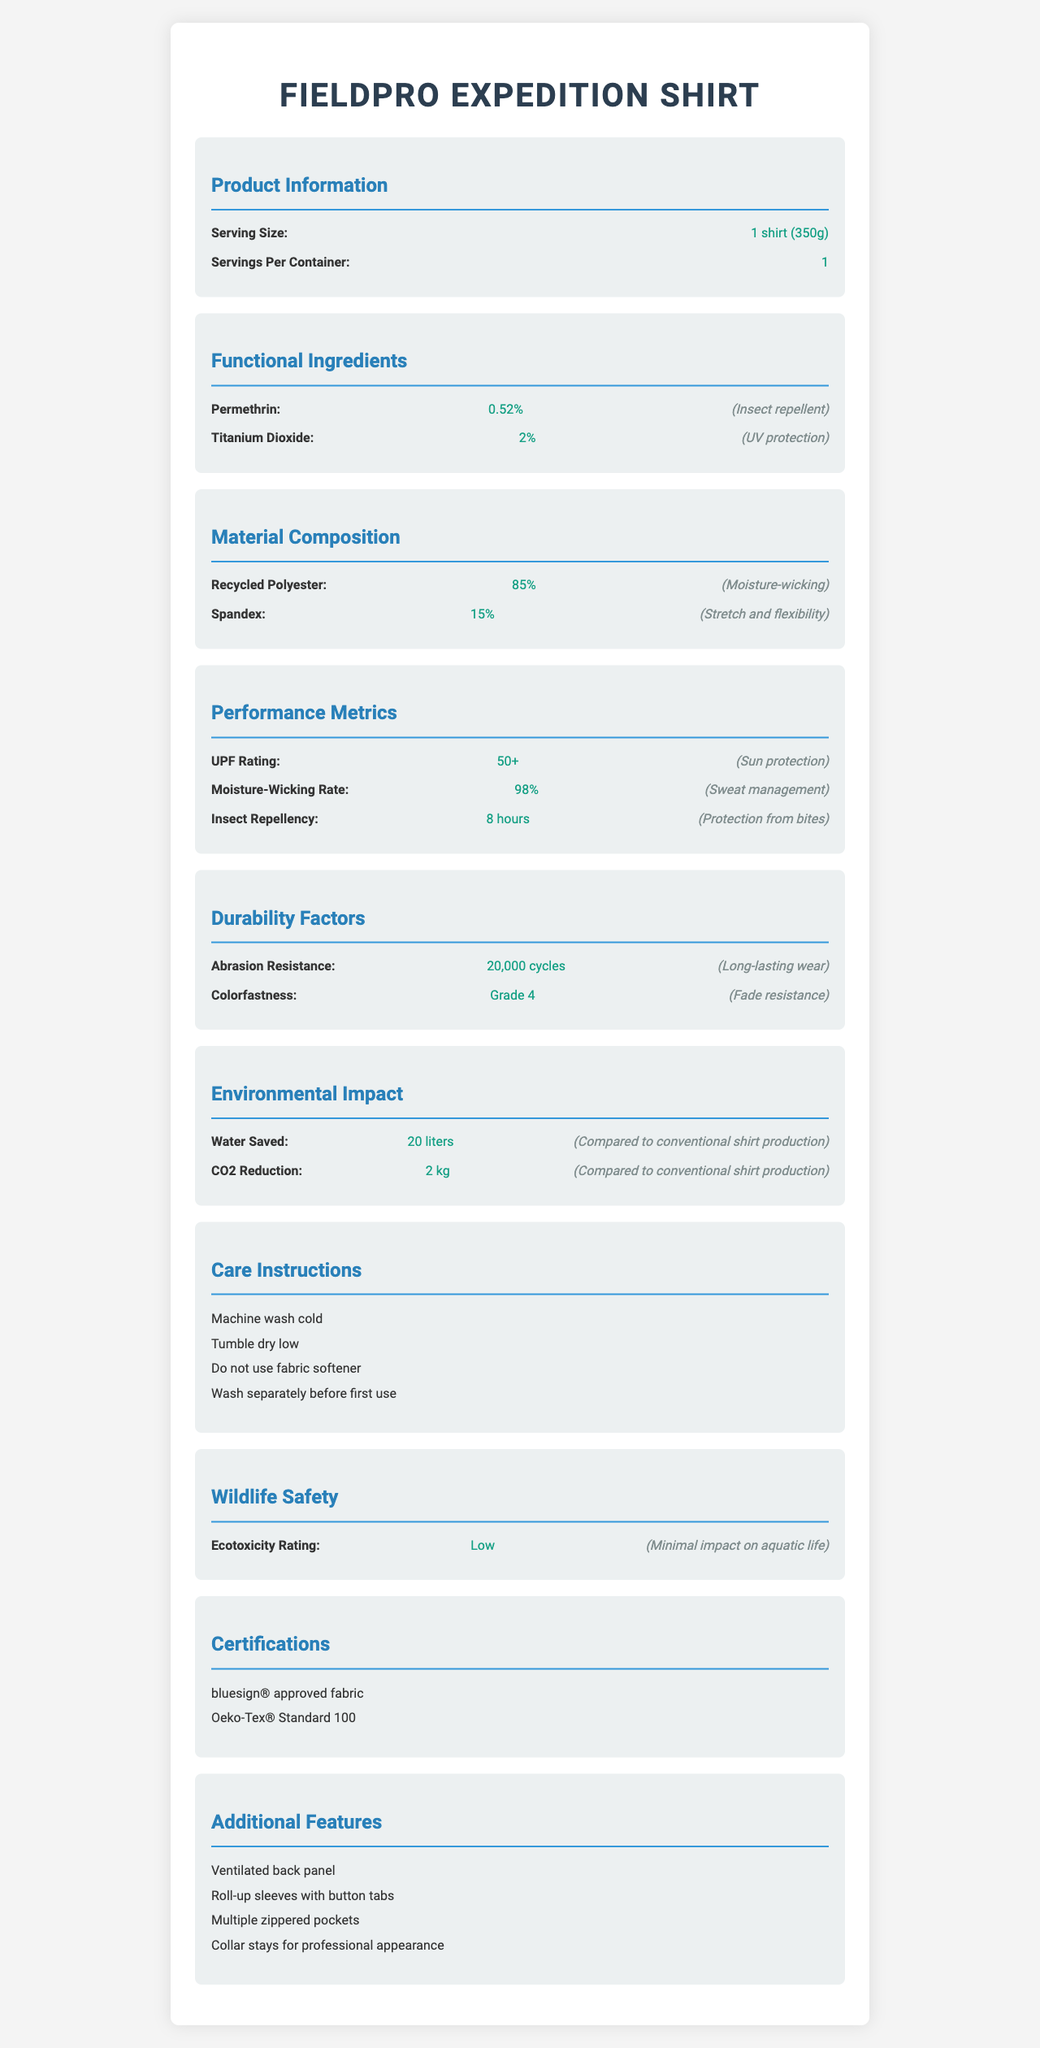what is the serving size for the FieldPro Expedition Shirt? The serving size is provided in the document under "Product Information" and is listed as "1 shirt (350g)".
Answer: 1 shirt (350g) how many servings are there per container? The document states under the "Product Information" section that there is 1 serving per container.
Answer: 1 what is the UPF rating of the shirt? The UPF rating is found under the "Performance Metrics" section, and it is listed as 50+.
Answer: 50+ what percentage of the shirt's material is recycled polyester? The "Material Composition" section lists that 85% of the shirt is made of Recycled Polyester.
Answer: 85% how much spandex is in the shirt's material composition? The "Material Composition" section shows that the shirt contains 15% Spandex.
Answer: 15% what is the main benefit of Permethrin in the shirt? The document lists Permethrin in the "Functional Ingredients" section, with its benefit specified as "Insect repellent".
Answer: Insect repellent how long does the insect repellency of the shirt last? The "Performance Metrics" section indicates that the insect repellency lasts for 8 hours.
Answer: 8 hours how much water is saved in producing the shirt compared to conventional production? The "Environmental Impact" section states that 20 liters of water is saved compared to conventional shirt production.
Answer: 20 liters which of the following certifications does the FieldPro Expedition Shirt have? A. Fair Trade Certified B. bluesign® approved fabric C. GOTS Certified D. EcoCert The document lists the certifications under the "Certifications" section and includes "bluesign® approved fabric" as one of them.
Answer: B. bluesign® approved fabric what is the shirt's abrasion resistance rating? A. 5,000 cycles B. 10,000 cycles C. 15,000 cycles D. 20,000 cycles The shirt's abrasion resistance, listed in the "Durability Factors" section, is 20,000 cycles.
Answer: D. 20,000 cycles is the shirt designed to minimize impact on aquatic life? The "Wildlife Safety" section indicates that the shirt has a low ecotoxicity rating, meaning it has minimal impact on aquatic life.
Answer: Yes summarize the main features and benefits of the FieldPro Expedition Shirt. This summary captures the essential features and benefits outlined in various sections of the document, including functional ingredients, material composition, performance metrics, durability, environmental impact, and additional features.
Answer: The FieldPro Expedition Shirt provides functionality and sustainability for fieldwork. It features insect repellency (Permethrin), UV protection (Titanium Dioxide), moisture-wicking and flexibility (Recycled Polyester and Spandex). Performance metrics include a UPF rating of 50+, an 8-hour insect repellency, and a 98% moisture-wicking rate. Durability factors like 20,000 cycles of abrasion resistance and Grade 4 colorfastness ensure long-lasting wear. Produced with eco-friendly practices, it saves 20 liters of water and reduces CO2 emissions by 2 kg. Care instructions include machine washing cold and tumble drying low, and certifications include bluesign® and Oeko-Tex®. Additional features are a ventilated back panel, roll-up sleeves, multiple zippered pockets, and collar stays. does this document provide the price of the FieldPro Expedition Shirt? The document contains detailed information about the shirt’s materials, features, and performance but does not mention the price.
Answer: No when should you wash the FieldPro Expedition Shirt separately? The care instructions specify to "Wash separately before first use", so this is when it should be washed separately.
Answer: Before first use what is the benefit of the Titanium Dioxide in the shirt? The "Functional Ingredients" section lists Titanium Dioxide with the benefit of UV protection.
Answer: UV protection 